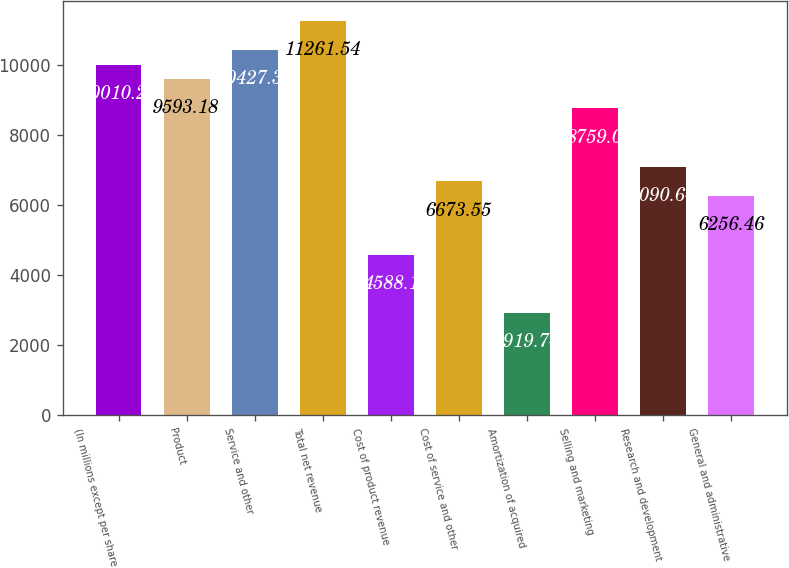<chart> <loc_0><loc_0><loc_500><loc_500><bar_chart><fcel>(In millions except per share<fcel>Product<fcel>Service and other<fcel>Total net revenue<fcel>Cost of product revenue<fcel>Cost of service and other<fcel>Amortization of acquired<fcel>Selling and marketing<fcel>Research and development<fcel>General and administrative<nl><fcel>10010.3<fcel>9593.18<fcel>10427.4<fcel>11261.5<fcel>4588.1<fcel>6673.55<fcel>2919.74<fcel>8759<fcel>7090.64<fcel>6256.46<nl></chart> 